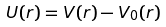<formula> <loc_0><loc_0><loc_500><loc_500>U ( r ) = V ( r ) - V _ { 0 } ( r )</formula> 